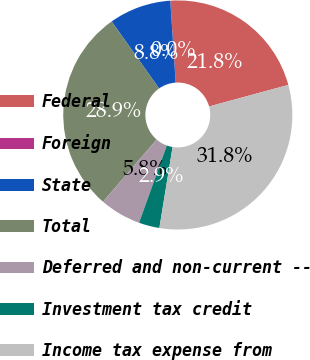<chart> <loc_0><loc_0><loc_500><loc_500><pie_chart><fcel>Federal<fcel>Foreign<fcel>State<fcel>Total<fcel>Deferred and non-current --<fcel>Investment tax credit<fcel>Income tax expense from<nl><fcel>21.81%<fcel>0.01%<fcel>8.75%<fcel>28.88%<fcel>5.83%<fcel>2.92%<fcel>31.79%<nl></chart> 